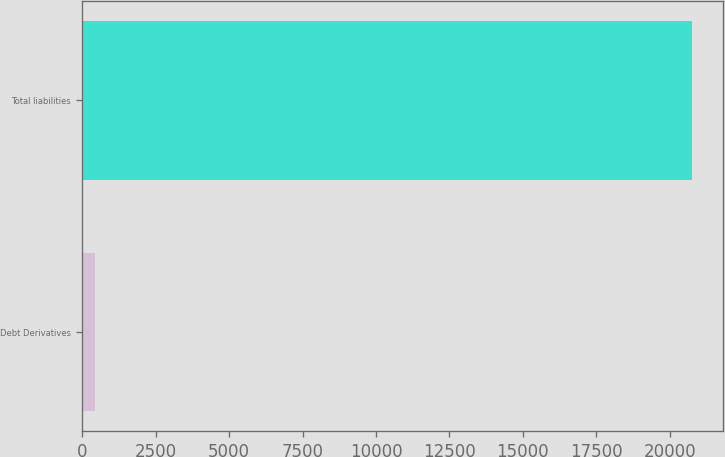Convert chart. <chart><loc_0><loc_0><loc_500><loc_500><bar_chart><fcel>Debt Derivatives<fcel>Total liabilities<nl><fcel>424<fcel>20763<nl></chart> 